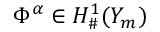Convert formula to latex. <formula><loc_0><loc_0><loc_500><loc_500>\Phi ^ { \alpha } \in H _ { \# } ^ { 1 } ( Y _ { m } )</formula> 